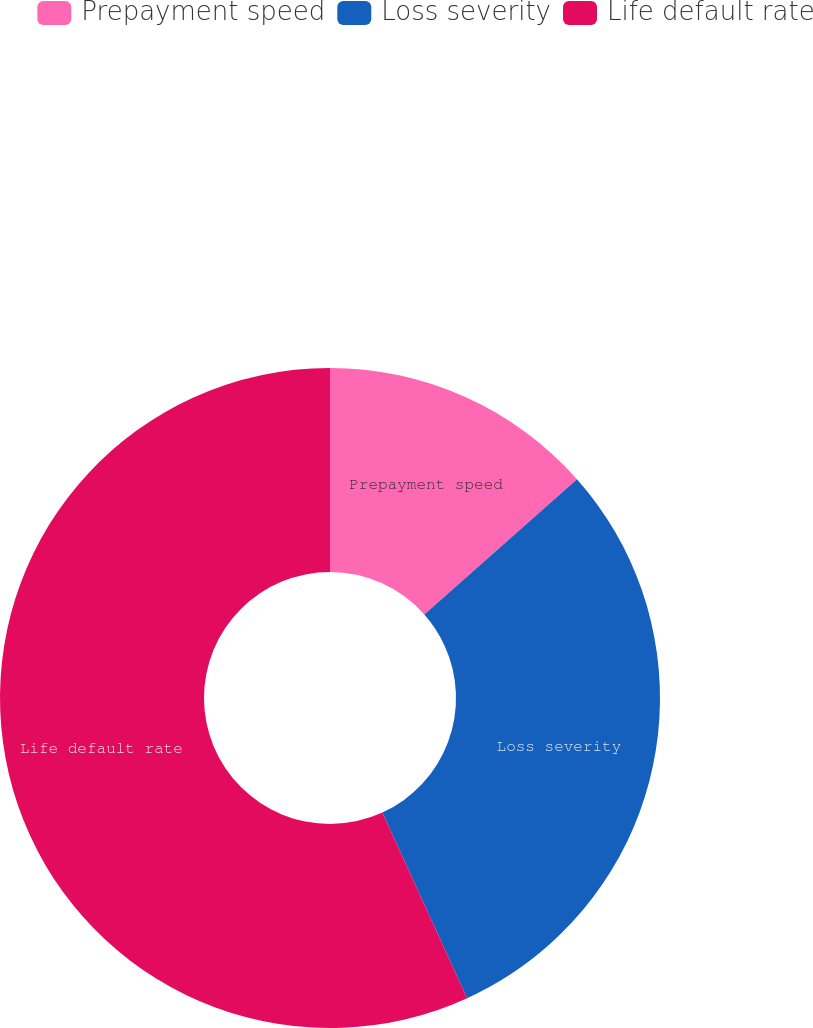Convert chart. <chart><loc_0><loc_0><loc_500><loc_500><pie_chart><fcel>Prepayment speed<fcel>Loss severity<fcel>Life default rate<nl><fcel>13.46%<fcel>29.72%<fcel>56.82%<nl></chart> 